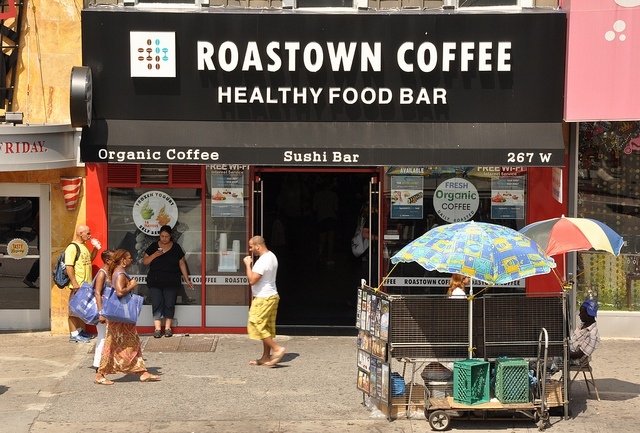Describe the objects in this image and their specific colors. I can see umbrella in black, lightblue, lightgray, and khaki tones, people in black, brown, maroon, tan, and gray tones, people in black, white, tan, khaki, and olive tones, umbrella in black, salmon, lightyellow, and darkgray tones, and people in black, maroon, and brown tones in this image. 